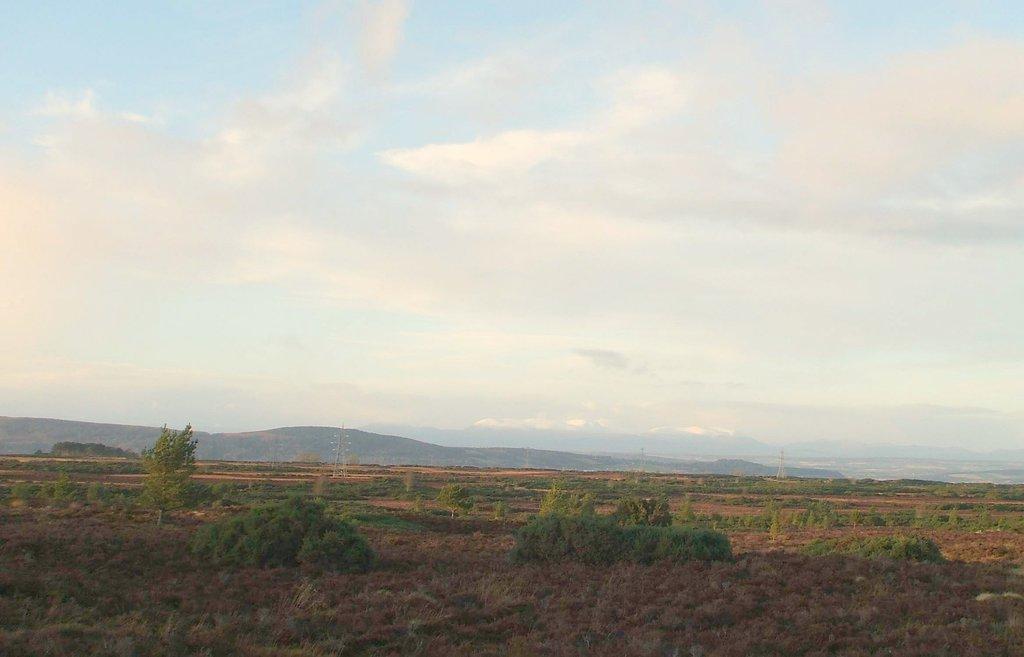Describe this image in one or two sentences. In this picture we can see there are trees, hills and electric steel poles. At the top of the image, there is the cloudy sky. 